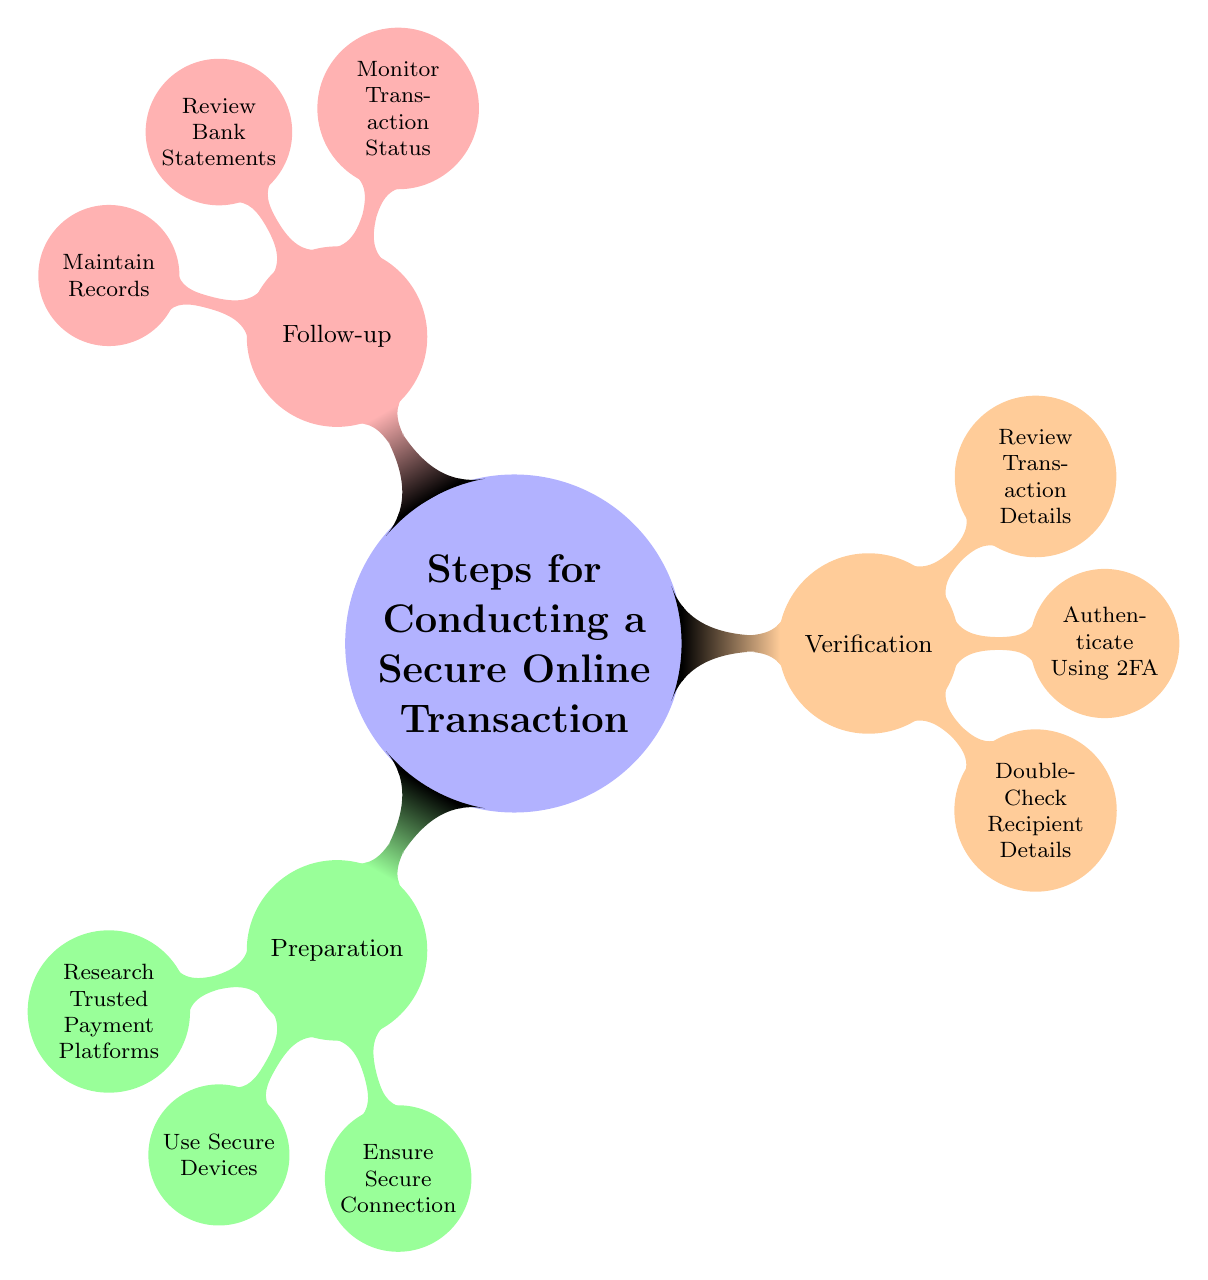What is the main topic of the mind map? The central node of the mind map, which represents the main idea, is "Steps for Conducting a Secure Online Transaction." This is the first node displayed and serves as an overview for the entire diagram.
Answer: Steps for Conducting a Secure Online Transaction How many main categories are there in the diagram? There are three main categories connected to the central node: Preparation, Verification, and Follow-up. Each of these is a top-level child node.
Answer: 3 What is one sub-category under Preparation? The sub-categories under Preparation include "Research Trusted Payment Platforms," "Use Secure Devices," and "Ensure Secure Connection." Any of these can be chosen as an answer as they are all valid sub-categories.
Answer: Research Trusted Payment Platforms Which category includes "Authenticate Using Two-Factor Authentication (2FA)"? "Authenticate Using Two-Factor Authentication (2FA)" is a sub-category under Verification. This can be determined by tracing from the central node to the outer layers of the mind map.
Answer: Verification Name one method listed under "Use Secure Devices." One of the methods listed under "Use Secure Devices" is "Updated Antivirus." This can be found by looking at the sub-categories under Preparation.
Answer: Updated Antivirus How many steps are there in the Follow-up category? The Follow-up category includes three distinct steps: "Monitor Transaction Status," "Review Bank Statements," and "Maintain Records." Therefore, when counting, we find that there are three steps.
Answer: 3 Which two categories focus on pre-transaction and post-transaction processes? The Preparation category focuses on pre-transaction processes, while the Follow-up category is concerned with post-transaction processes. By analyzing the roles of each category, it becomes clear which processes they refer to.
Answer: Preparation and Follow-up What type of information should be verified according to the Verification category? According to the Verification category, details such as recipient details, transaction details, and authentication methods should be verified. All of these contribute to ensuring the transaction's security.
Answer: Recipient details, transaction details, and authentication methods Which step in the Follow-up category deals with financial accountability? "Review Bank Statements" deals with financial accountability by ensuring that all transactions are accounted for and match transaction records. This is crucial for identifying any discrepancies.
Answer: Review Bank Statements 